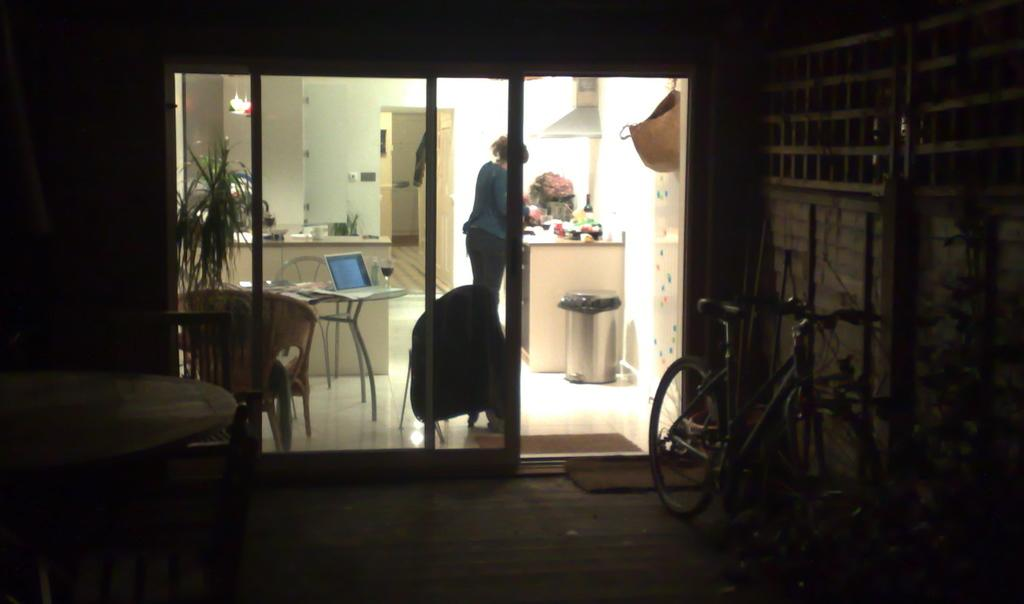What is the woman doing in the image? The woman is doing something at a counter. What objects can be seen on the table in the image? There is a laptop and a wine glass on the table. Is there any exercise equipment in the image? Yes, there is a cycle beside the door of the room. What type of hat is the woman wearing in the image? There is no hat visible in the image. 